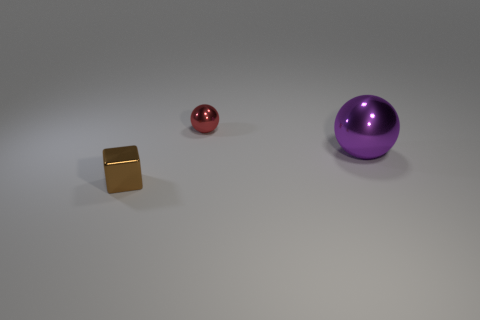What material is the small object that is behind the small metal object in front of the big shiny ball?
Ensure brevity in your answer.  Metal. Do the red sphere and the tiny thing that is on the left side of the small metal sphere have the same material?
Provide a succinct answer. Yes. What number of objects are either tiny metal objects that are on the right side of the metal block or big brown cylinders?
Provide a short and direct response. 1. Is there a cube that has the same color as the big sphere?
Keep it short and to the point. No. There is a large purple object; does it have the same shape as the tiny metallic object in front of the large object?
Provide a succinct answer. No. What number of objects are on the left side of the large purple metal thing and in front of the small red metal object?
Offer a terse response. 1. There is a metal thing that is left of the tiny thing that is to the right of the small brown block; how big is it?
Give a very brief answer. Small. Are any big purple metal objects visible?
Ensure brevity in your answer.  Yes. What material is the object that is in front of the red sphere and on the left side of the large thing?
Ensure brevity in your answer.  Metal. Is the number of small red objects that are right of the big ball greater than the number of brown cubes that are to the right of the tiny sphere?
Offer a terse response. No. 